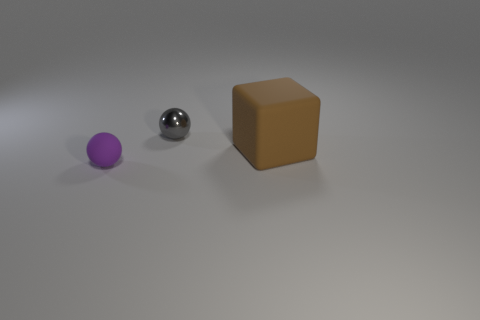Add 2 small purple rubber objects. How many objects exist? 5 Subtract all purple balls. How many balls are left? 1 Subtract all blocks. How many objects are left? 2 Subtract 0 blue blocks. How many objects are left? 3 Subtract 1 cubes. How many cubes are left? 0 Subtract all green blocks. Subtract all brown balls. How many blocks are left? 1 Subtract all brown shiny balls. Subtract all brown rubber things. How many objects are left? 2 Add 3 purple objects. How many purple objects are left? 4 Add 3 small blue metallic balls. How many small blue metallic balls exist? 3 